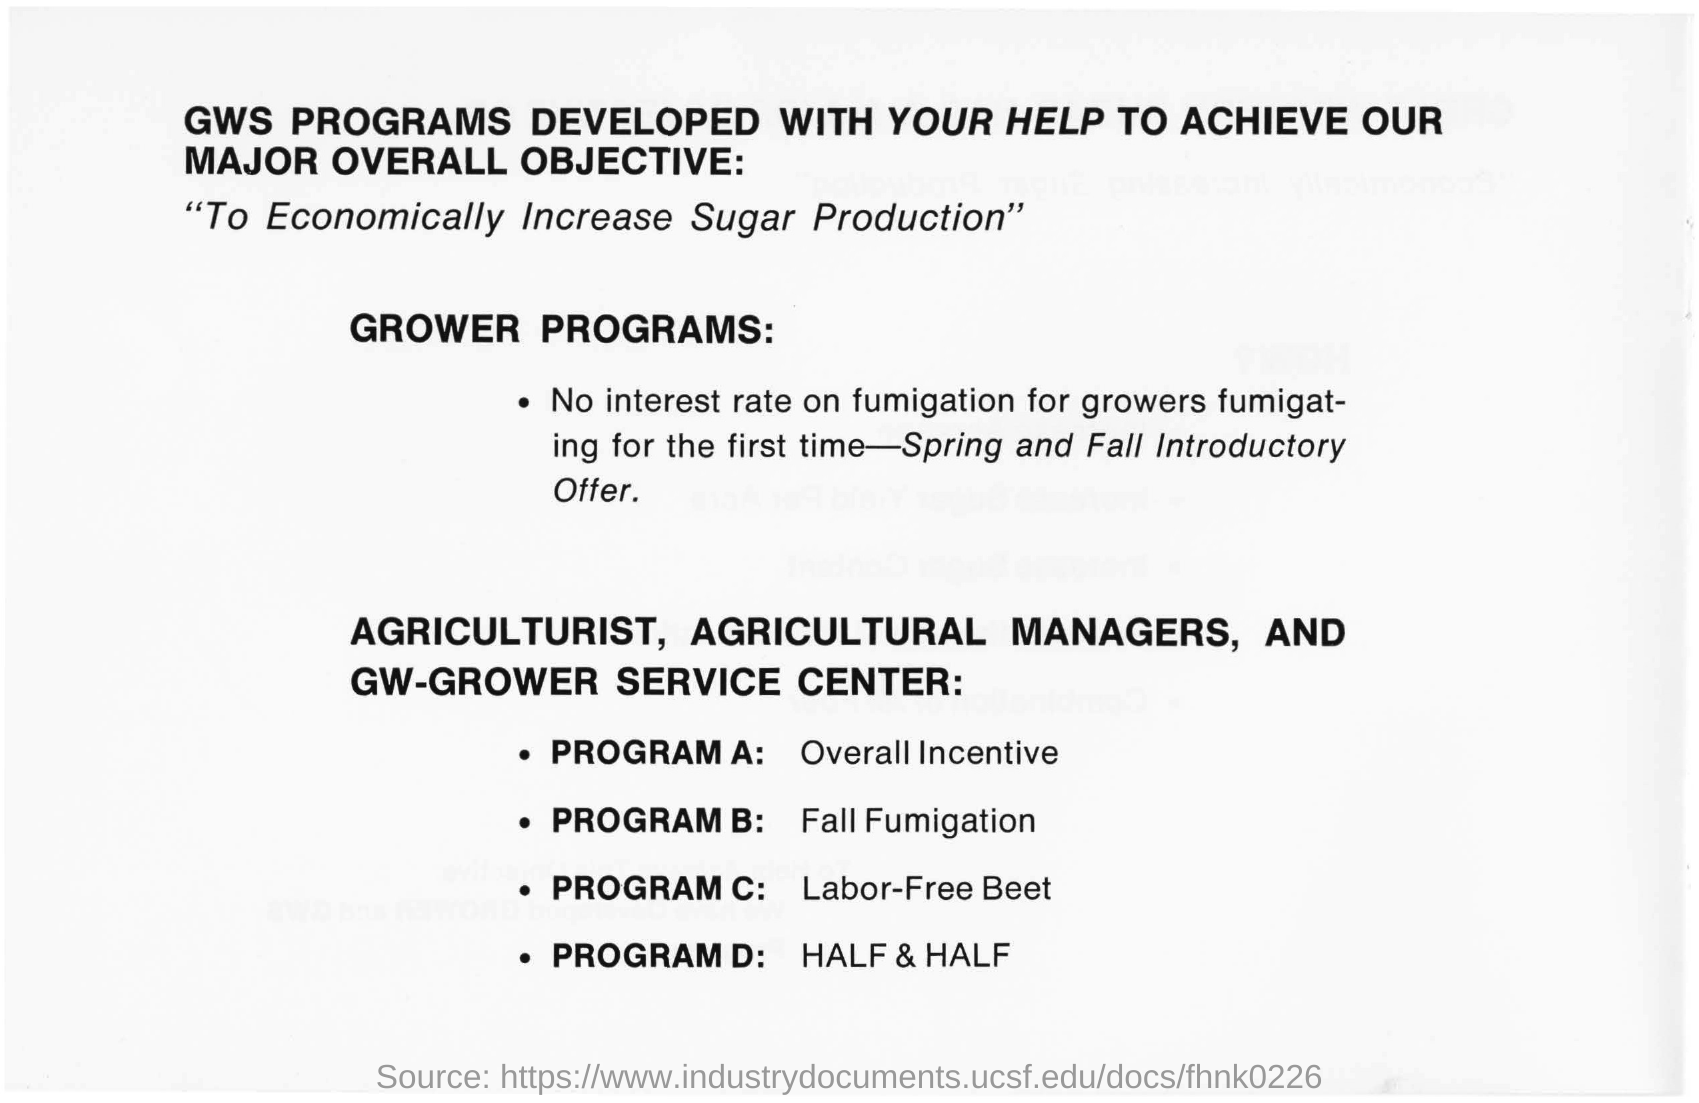Outline some significant characteristics in this image. The program C is a labor-free beet-based initiative that aims to provide efficient and effective solutions for various tasks. What is Program A about? It is related to overall incentives. The program is Fall Fumigation for Program B. What is Program D? It involves using half and half. 